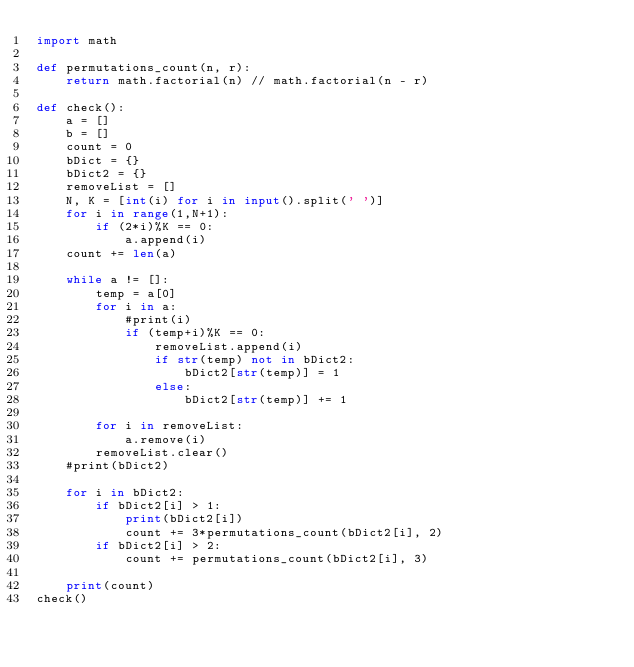Convert code to text. <code><loc_0><loc_0><loc_500><loc_500><_Python_>import math

def permutations_count(n, r):
    return math.factorial(n) // math.factorial(n - r)

def check():
    a = []
    b = []
    count = 0
    bDict = {}
    bDict2 = {}
    removeList = []
    N, K = [int(i) for i in input().split(' ')]
    for i in range(1,N+1):
        if (2*i)%K == 0:
            a.append(i)
    count += len(a)

    while a != []:
        temp = a[0]
        for i in a:
            #print(i)
            if (temp+i)%K == 0:
                removeList.append(i)
                if str(temp) not in bDict2:
                    bDict2[str(temp)] = 1
                else:
                    bDict2[str(temp)] += 1  
                    
        for i in removeList:
            a.remove(i)
        removeList.clear()
    #print(bDict2)
            
    for i in bDict2:
        if bDict2[i] > 1:
            print(bDict2[i])
            count += 3*permutations_count(bDict2[i], 2)
        if bDict2[i] > 2:
            count += permutations_count(bDict2[i], 3)

    print(count)
check()</code> 